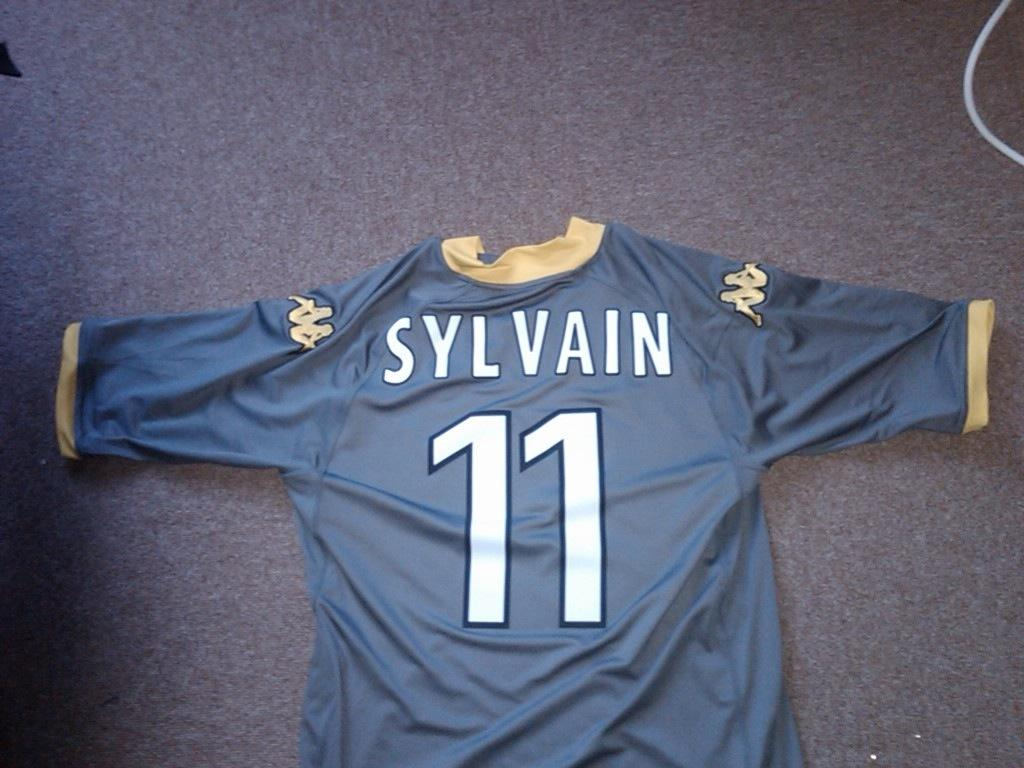Provide a one-sentence caption for the provided image. A jersey shirt, with the words Sylvain 11 on it. 